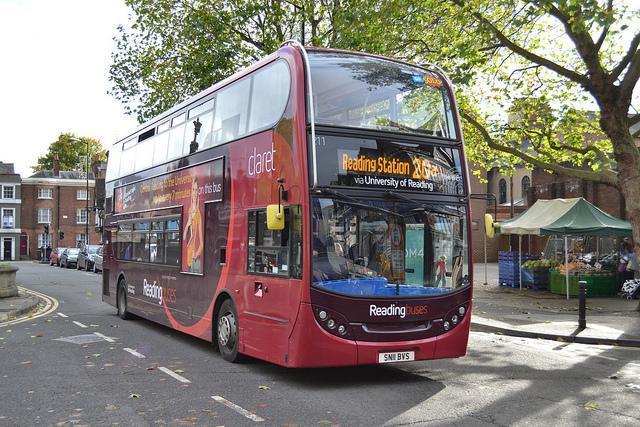How many levels are on the bus?
Give a very brief answer. 2. How many buses are in the picture?
Give a very brief answer. 1. How many windows on this airplane are touched by red or orange paint?
Give a very brief answer. 0. 